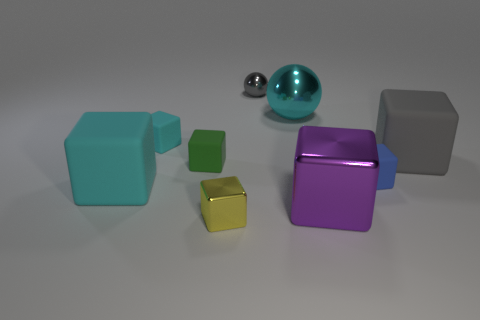Subtract all big metal blocks. How many blocks are left? 6 Subtract all green cubes. How many cubes are left? 6 Subtract all green blocks. Subtract all blue spheres. How many blocks are left? 6 Subtract all balls. How many objects are left? 7 Subtract 0 cyan cylinders. How many objects are left? 9 Subtract all big cyan metal objects. Subtract all large shiny blocks. How many objects are left? 7 Add 1 big rubber things. How many big rubber things are left? 3 Add 7 green matte cubes. How many green matte cubes exist? 8 